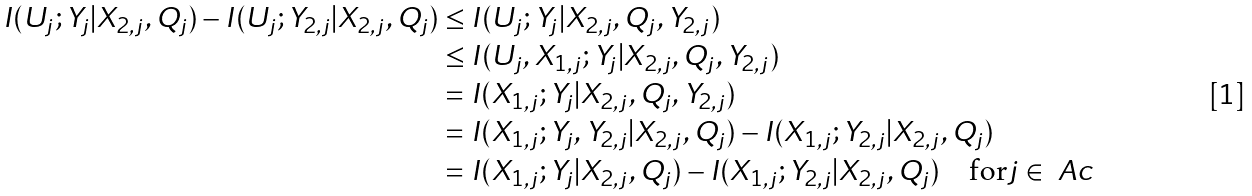Convert formula to latex. <formula><loc_0><loc_0><loc_500><loc_500>I ( U _ { j } ; Y _ { j } | X _ { 2 , j } , Q _ { j } ) - I ( U _ { j } ; Y _ { 2 , j } | X _ { 2 , j } , Q _ { j } ) & \leq I ( U _ { j } ; Y _ { j } | X _ { 2 , j } , Q _ { j } , Y _ { 2 , j } ) \\ & \leq I ( U _ { j } , X _ { 1 , j } ; Y _ { j } | X _ { 2 , j } , Q _ { j } , Y _ { 2 , j } ) \\ & = I ( X _ { 1 , j } ; Y _ { j } | X _ { 2 , j } , Q _ { j } , Y _ { 2 , j } ) \\ & = I ( X _ { 1 , j } ; Y _ { j } , Y _ { 2 , j } | X _ { 2 , j } , Q _ { j } ) - I ( X _ { 1 , j } ; Y _ { 2 , j } | X _ { 2 , j } , Q _ { j } ) \\ & = I ( X _ { 1 , j } ; Y _ { j } | X _ { 2 , j } , Q _ { j } ) - I ( X _ { 1 , j } ; Y _ { 2 , j } | X _ { 2 , j } , Q _ { j } ) \quad \text {for} j \in \ A c</formula> 